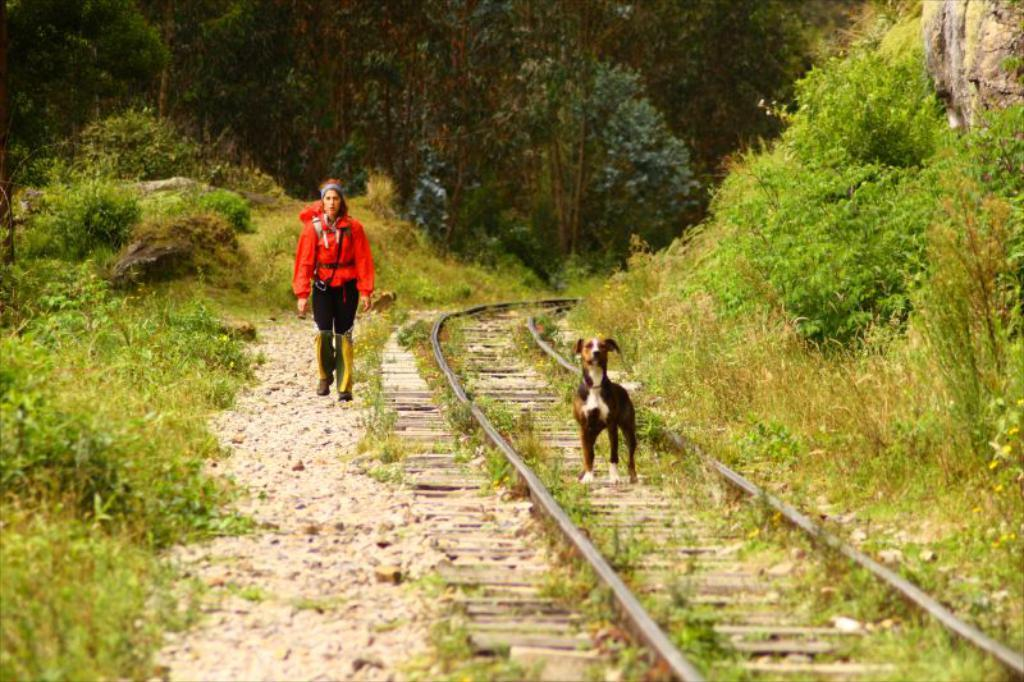Who is present in the image? There is a woman in the image. What other living creature can be seen in the image? There is a dog in the image. What type of man-made structure is visible in the image? There is a railway track in the image. What type of natural environment is visible in the image? There is grass, plants, and trees visible in the image. What type of quartz can be seen in the image? There is no quartz present in the image. Is there a cobweb visible in the image? There is no cobweb visible in the image. 